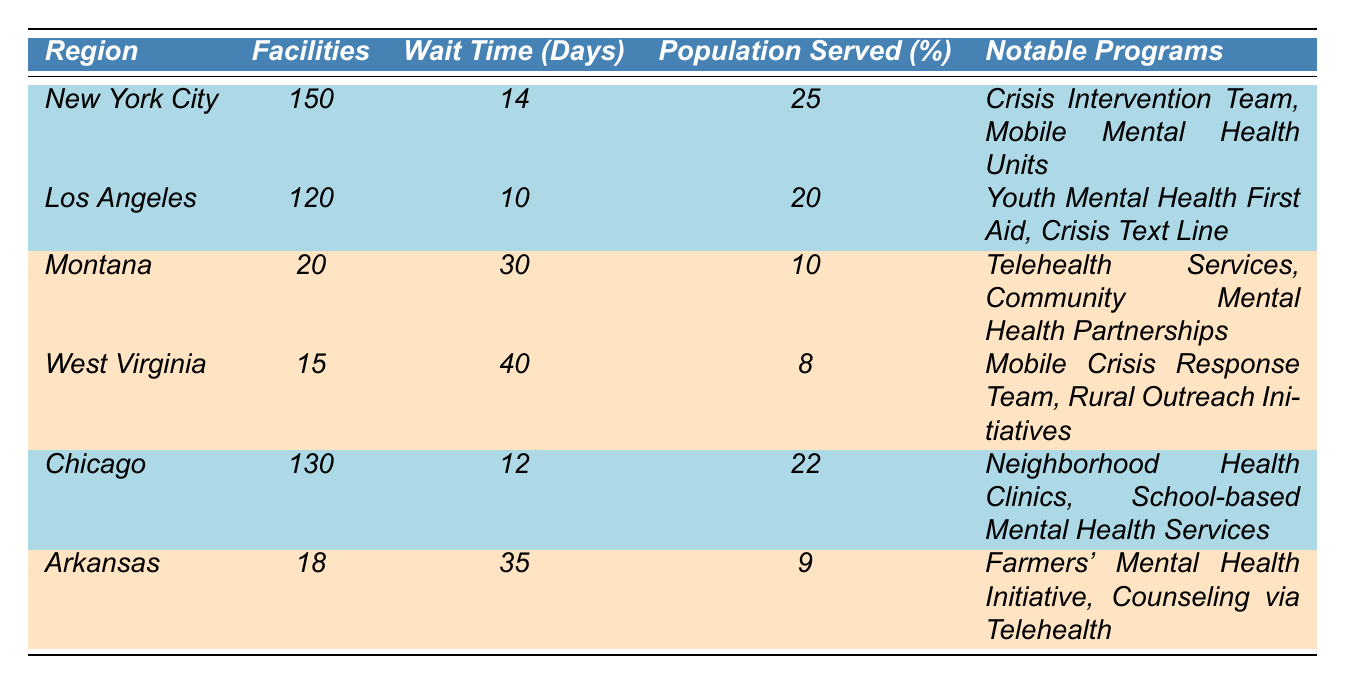What is the average wait time for mental health services in urban areas? To find the average wait time for urban areas, we look at the facilities in New York City, Los Angeles, and Chicago which have wait times of 14, 10, and 12 days respectively. We sum these wait times: 14 + 10 + 12 = 36 days. Then, we divide by the number of urban facilities, which is 3: 36 / 3 = 12 days.
Answer: 12 days Which city has the highest number of mental health facilities? By examining the table, we see that New York City has 150 mental health facilities, which is higher than Los Angeles (120) and Chicago (130). Therefore, New York City has the highest number of facilities.
Answer: New York City What percentage of the population is served by mental health services in West Virginia? According to the table, West Virginia serves 8% of its population through mental health services, as specified in the data presented.
Answer: 8% Do urban areas typically have a shorter wait time for mental health services than rural areas? To compare wait times, we look at the average wait times for urban (14, 10, 12 days) and rural areas (30, 40, 35 days). The average for urban areas is 12 days, while for rural areas it is (30 + 40 + 35) / 3 = 35 days. Since 12 < 35, urban areas generally have shorter wait times than rural areas.
Answer: Yes How many mental health facilities are there in total, both urban and rural? We add the number of facilities across all regions: New York City (150) + Los Angeles (120) + Chicago (130) + Montana (20) + West Virginia (15) + Arkansas (18) = 150 + 120 + 130 + 20 + 15 + 18 = 453. Therefore, the total number of facilities is 453.
Answer: 453 Is there a notable program called "Crisis Text Line" in rural areas? Looking at the notable programs for rural areas, we see that only Montana and Arkansas list their specific programs. Neither of these states includes "Crisis Text Line," which is associated with Los Angeles, an urban area. Therefore, the answer is no.
Answer: No How does the percentage of the population served in Montana compare to that of Arkansas? Montana serves 10% of its population, while Arkansas serves 9%. Therefore, we compare these values: 10% > 9%, indicating that Montana serves a higher percentage of the population than Arkansas.
Answer: Montana serves a higher percentage What notable programs are available in Chicago, and how many facilities does it have? In Chicago, the notable programs include "Neighborhood Health Clinics" and "School-based Mental Health Services," and the city has 130 facilities.
Answer: Neighborhood Health Clinics, School-based Mental Health Services; 130 facilities Which region has the lowest percentage of population served by mental health services? From the data, we see that West Virginia serves 8% of the population, which is lower than the percentages served in all other regions listed, making it the region with the lowest percentage served.
Answer: West Virginia What is the difference in the number of facilities between New York City and West Virginia? New York City has 150 facilities while West Virginia has 15 facilities. The difference is calculated by subtracting the number of facilities in West Virginia from those in New York City: 150 - 15 = 135.
Answer: 135 facilities 